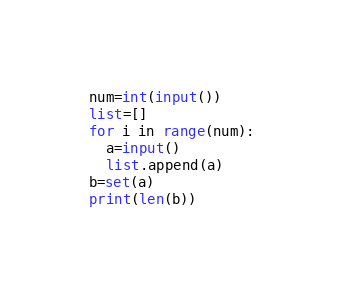<code> <loc_0><loc_0><loc_500><loc_500><_Python_>num=int(input())
list=[]
for i in range(num):
  a=input()
  list.append(a)
b=set(a)
print(len(b))</code> 